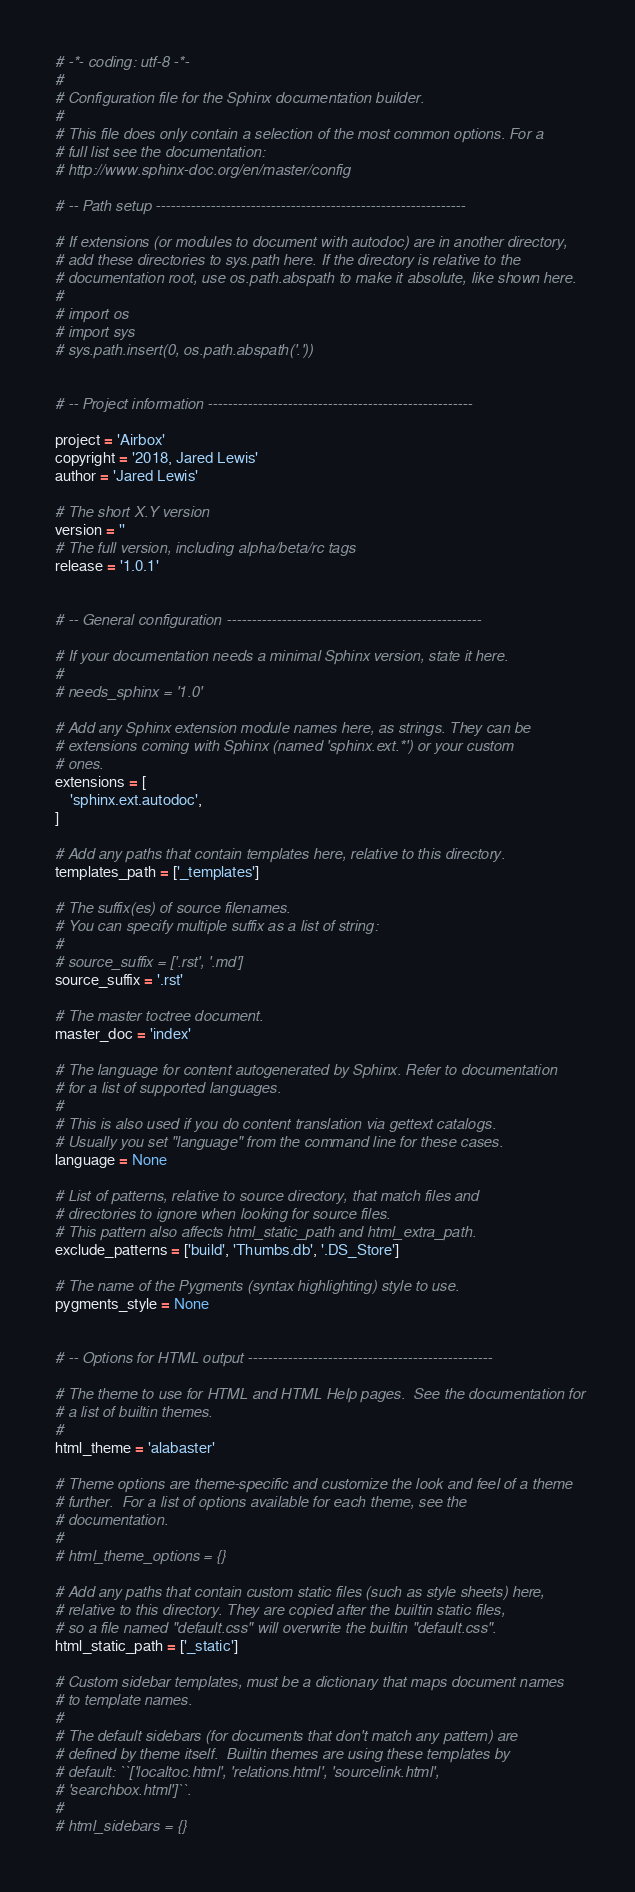<code> <loc_0><loc_0><loc_500><loc_500><_Python_># -*- coding: utf-8 -*-
#
# Configuration file for the Sphinx documentation builder.
#
# This file does only contain a selection of the most common options. For a
# full list see the documentation:
# http://www.sphinx-doc.org/en/master/config

# -- Path setup --------------------------------------------------------------

# If extensions (or modules to document with autodoc) are in another directory,
# add these directories to sys.path here. If the directory is relative to the
# documentation root, use os.path.abspath to make it absolute, like shown here.
#
# import os
# import sys
# sys.path.insert(0, os.path.abspath('.'))


# -- Project information -----------------------------------------------------

project = 'Airbox'
copyright = '2018, Jared Lewis'
author = 'Jared Lewis'

# The short X.Y version
version = ''
# The full version, including alpha/beta/rc tags
release = '1.0.1'


# -- General configuration ---------------------------------------------------

# If your documentation needs a minimal Sphinx version, state it here.
#
# needs_sphinx = '1.0'

# Add any Sphinx extension module names here, as strings. They can be
# extensions coming with Sphinx (named 'sphinx.ext.*') or your custom
# ones.
extensions = [
    'sphinx.ext.autodoc',
]

# Add any paths that contain templates here, relative to this directory.
templates_path = ['_templates']

# The suffix(es) of source filenames.
# You can specify multiple suffix as a list of string:
#
# source_suffix = ['.rst', '.md']
source_suffix = '.rst'

# The master toctree document.
master_doc = 'index'

# The language for content autogenerated by Sphinx. Refer to documentation
# for a list of supported languages.
#
# This is also used if you do content translation via gettext catalogs.
# Usually you set "language" from the command line for these cases.
language = None

# List of patterns, relative to source directory, that match files and
# directories to ignore when looking for source files.
# This pattern also affects html_static_path and html_extra_path.
exclude_patterns = ['build', 'Thumbs.db', '.DS_Store']

# The name of the Pygments (syntax highlighting) style to use.
pygments_style = None


# -- Options for HTML output -------------------------------------------------

# The theme to use for HTML and HTML Help pages.  See the documentation for
# a list of builtin themes.
#
html_theme = 'alabaster'

# Theme options are theme-specific and customize the look and feel of a theme
# further.  For a list of options available for each theme, see the
# documentation.
#
# html_theme_options = {}

# Add any paths that contain custom static files (such as style sheets) here,
# relative to this directory. They are copied after the builtin static files,
# so a file named "default.css" will overwrite the builtin "default.css".
html_static_path = ['_static']

# Custom sidebar templates, must be a dictionary that maps document names
# to template names.
#
# The default sidebars (for documents that don't match any pattern) are
# defined by theme itself.  Builtin themes are using these templates by
# default: ``['localtoc.html', 'relations.html', 'sourcelink.html',
# 'searchbox.html']``.
#
# html_sidebars = {}

</code> 